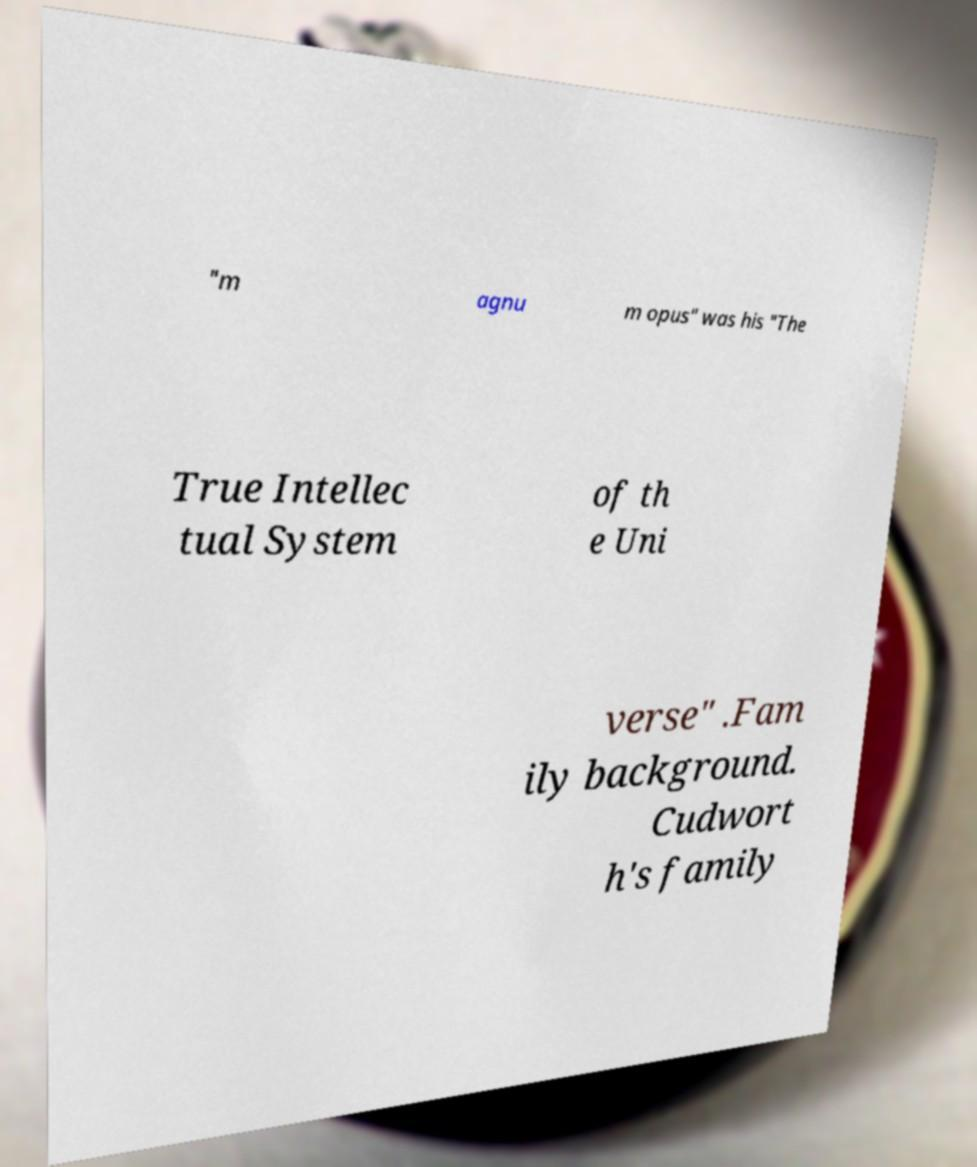Please read and relay the text visible in this image. What does it say? "m agnu m opus" was his "The True Intellec tual System of th e Uni verse" .Fam ily background. Cudwort h's family 